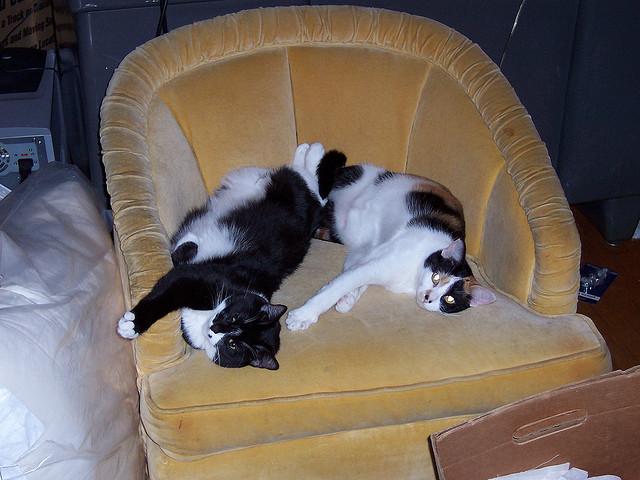How many cats are there?
Keep it brief. 2. Are the cats asleep?
Quick response, please. No. Where is the chair?
Keep it brief. Living room. 